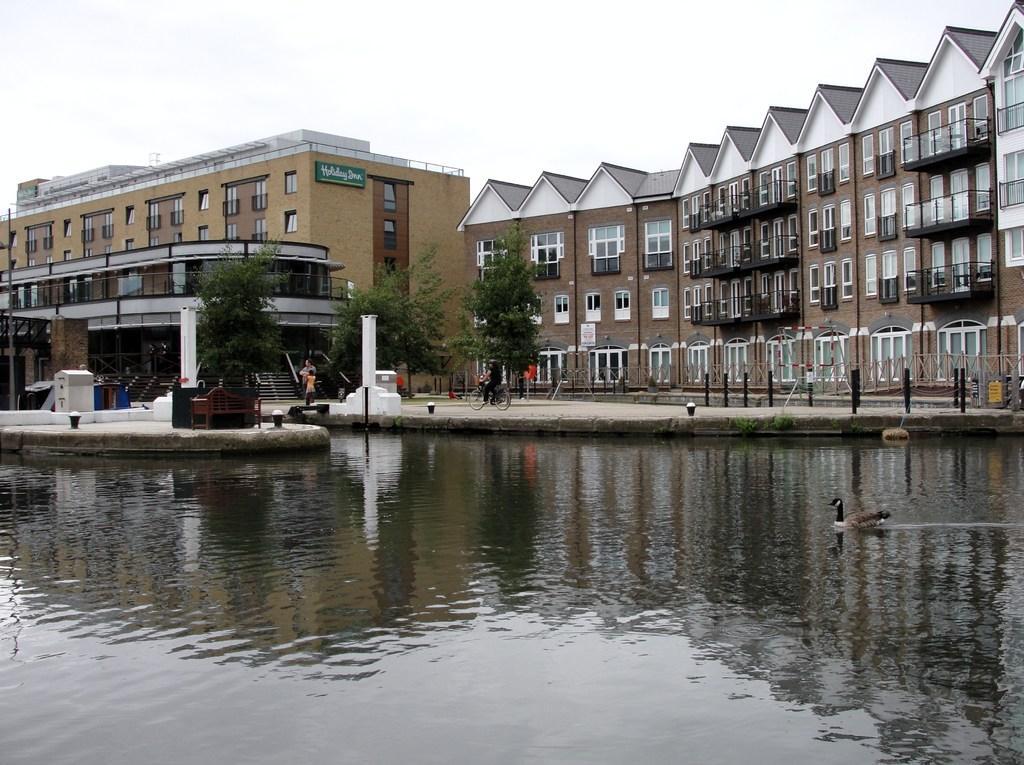Could you give a brief overview of what you see in this image? In this picture we can see a bird on water, here we can see buildings, trees, people, bicycle, poles and some objects and we can see sky in the background. 